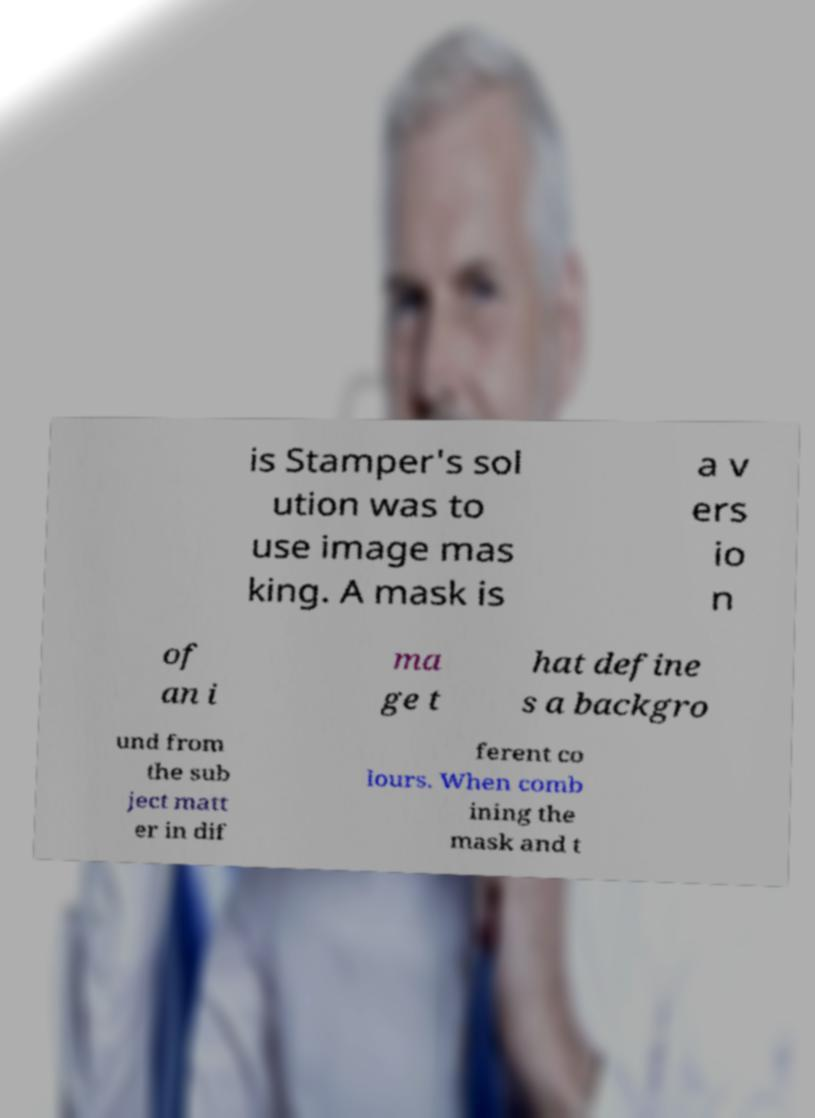Can you accurately transcribe the text from the provided image for me? is Stamper's sol ution was to use image mas king. A mask is a v ers io n of an i ma ge t hat define s a backgro und from the sub ject matt er in dif ferent co lours. When comb ining the mask and t 